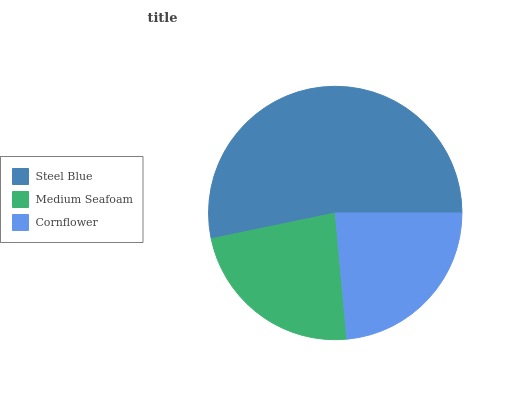Is Medium Seafoam the minimum?
Answer yes or no. Yes. Is Steel Blue the maximum?
Answer yes or no. Yes. Is Cornflower the minimum?
Answer yes or no. No. Is Cornflower the maximum?
Answer yes or no. No. Is Cornflower greater than Medium Seafoam?
Answer yes or no. Yes. Is Medium Seafoam less than Cornflower?
Answer yes or no. Yes. Is Medium Seafoam greater than Cornflower?
Answer yes or no. No. Is Cornflower less than Medium Seafoam?
Answer yes or no. No. Is Cornflower the high median?
Answer yes or no. Yes. Is Cornflower the low median?
Answer yes or no. Yes. Is Medium Seafoam the high median?
Answer yes or no. No. Is Steel Blue the low median?
Answer yes or no. No. 